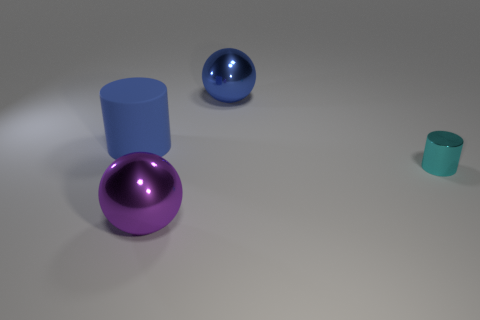Add 2 large blue cylinders. How many objects exist? 6 Subtract 0 yellow balls. How many objects are left? 4 Subtract all large purple metal spheres. Subtract all large purple metal spheres. How many objects are left? 2 Add 1 cyan things. How many cyan things are left? 2 Add 4 large purple objects. How many large purple objects exist? 5 